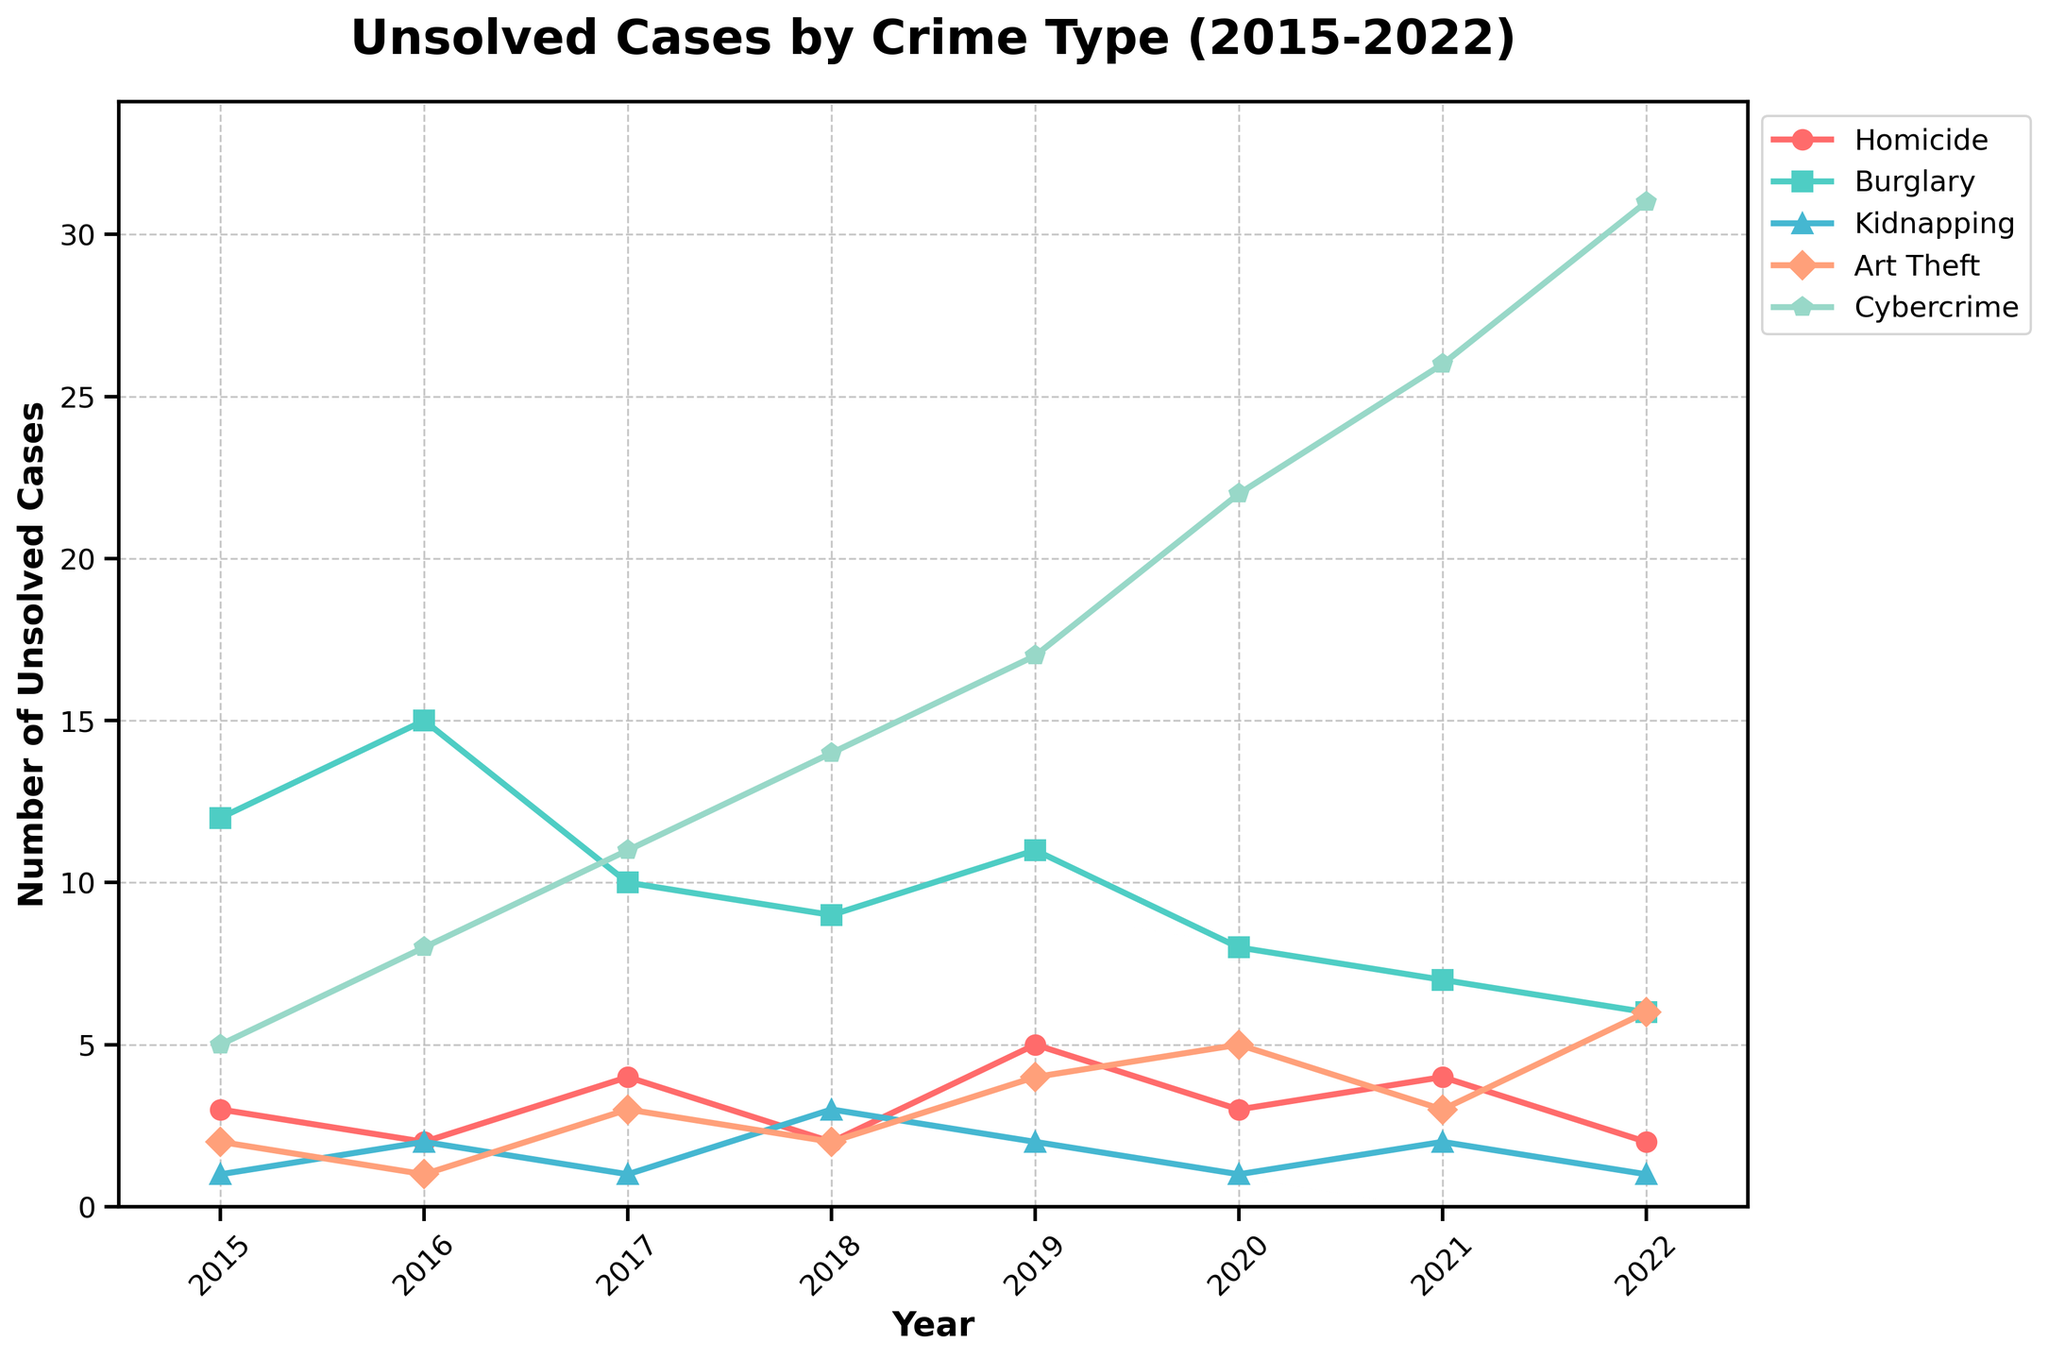What is the trend of unsolved Cybercrime cases from 2015 to 2022? To find the trend, look at the data points for Cybercrime from 2015 to 2022. The numbers are increasing every year: 5, 8, 11, 14, 17, 22, 26, 31. This indicates a rising trend in unsolved Cybercrime cases.
Answer: Rising Which crime type had the highest number of unsolved cases in 2022? To determine this, look at the vertical points of the lines at the year 2022. The Cybercrime line is the highest with 31 cases, indicating it's the crime type with the highest unsolved cases in 2022.
Answer: Cybercrime How did the number of unsolved Homicide cases change from 2018 to 2020? Observe the number of unsolved Homicide cases in 2018 and 2020. In 2018, there were 2 cases, and in 2020, there were 3 cases. This shows an increase of 1 case over this period.
Answer: Increased by 1 Which crime type has consistently lower unsolved cases compared to Art Theft from 2015 to 2022? Compare the trend lines for each crime type and notice the vertical points of Art Theft and each crime type from 2015 to 2022. Kidnapping consistently has lower numbers (1, 2, 1, 3, 2, 1, 2, 1) compared to Art Theft (2, 1, 3, 2, 4, 5, 3, 6).
Answer: Kidnapping What is the total number of unsolved cases for Burglary between 2015 and 2022? Sum the numbers for Burglary cases from 2015 to 2022: 12 + 15 + 10 + 9 + 11 + 8 + 7 + 6. This results in a total of 78 unsolved Burglary cases within the given period.
Answer: 78 In which year did Cybercrime see the highest increment in unsolved cases compared to the previous year? Check the year-to-year differences for Cybercrime: 5 to 8 (+3), 8 to 11 (+3), 11 to 14 (+3), 14 to 17 (+3), 17 to 22 (+5), 22 to 26 (+4), 26 to 31 (+5). The largest increments of +5 are between 2019-2020 and 2021-2022.
Answer: 2019-2020 and 2021-2022 Which year had the highest combined number of unsolved Homicide and Burglary cases? Add the values of unsolved Homicide and Burglary cases for each year and compare: 
2015: 3 + 12 = 15, 
2016: 2 + 15 = 17, 
2017: 4 + 10 = 14, 
2018: 2 + 9 = 11, 
2019: 5 + 11 = 16, 
2020: 3 + 8 = 11, 
2021: 4 + 7= 11,
2022: 2 + 6 = 8. The highest combined number is 17 in the year 2016.
Answer: 2016 What is the difference in the number of unsolved Kidnapping cases between 2017 and 2018? Compare the numbers for unsolved Kidnapping cases in 2017 and 2018. In 2017, there is 1 case and in 2018, there are 3 cases. The difference is 2 cases.
Answer: 2 